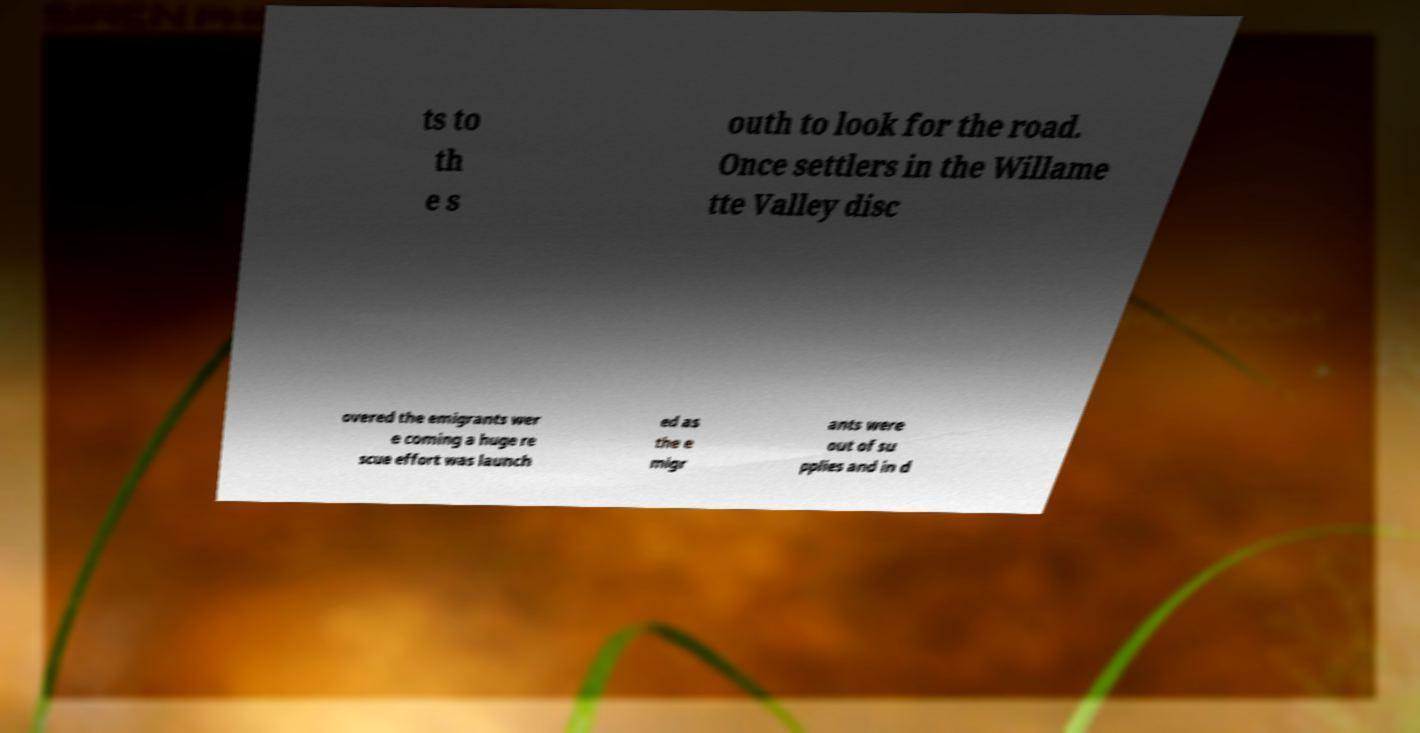Can you read and provide the text displayed in the image?This photo seems to have some interesting text. Can you extract and type it out for me? ts to th e s outh to look for the road. Once settlers in the Willame tte Valley disc overed the emigrants wer e coming a huge re scue effort was launch ed as the e migr ants were out of su pplies and in d 